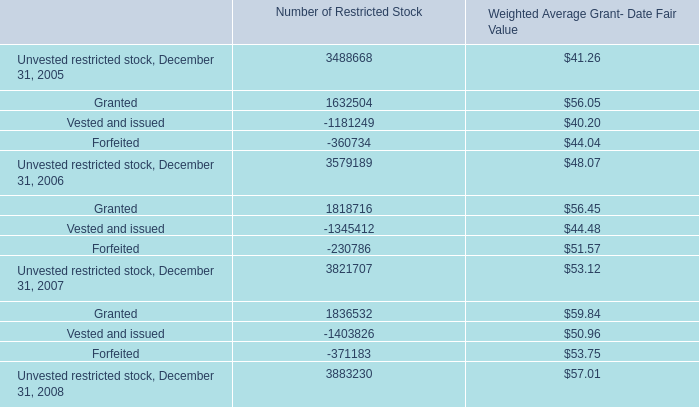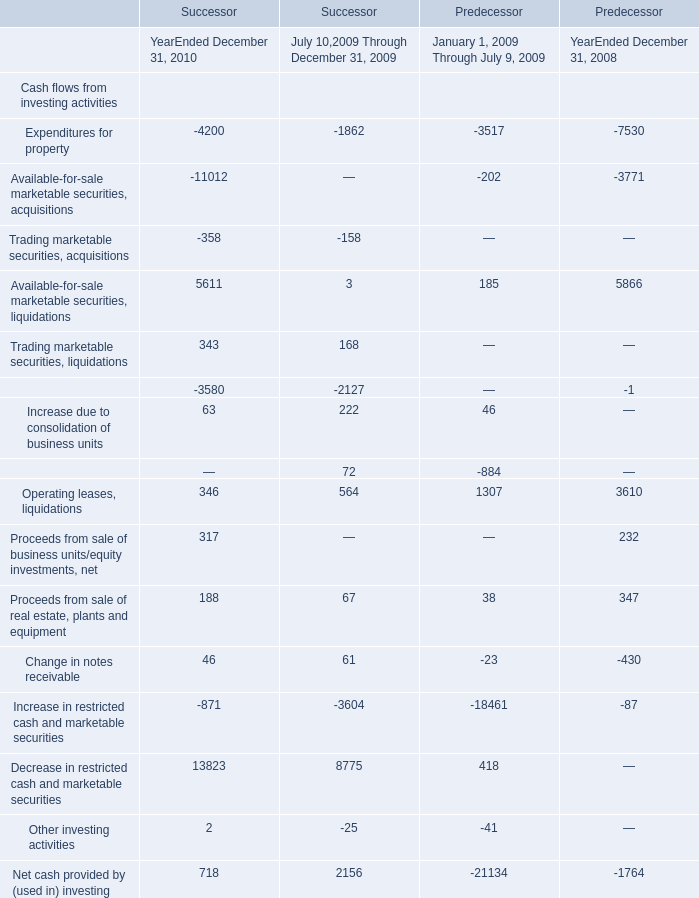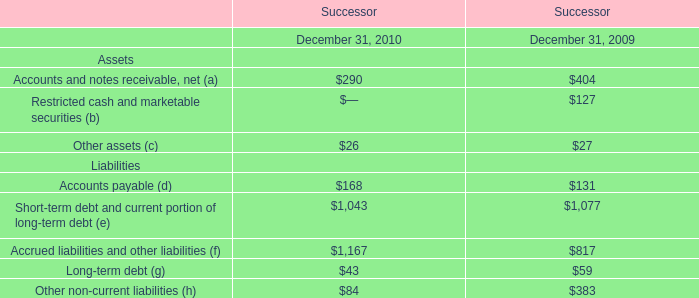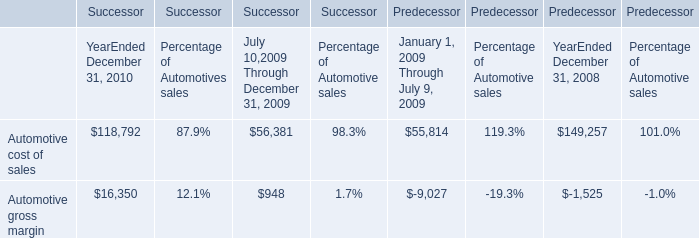What was the average value of Operating leases, liquidations, Proceeds from sale of real estate, plants and equipment, Proceeds from sale of business units/equity investments, net in 2010 for Successor? 
Computations: (((346 + 317) + 188) / 3)
Answer: 283.66667. 